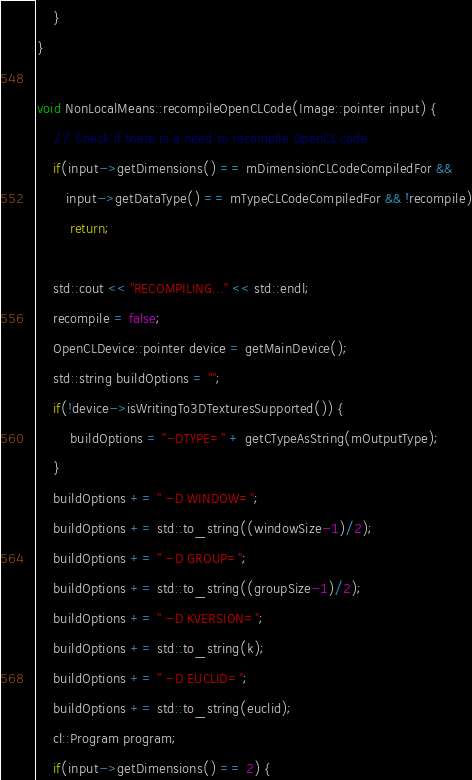Convert code to text. <code><loc_0><loc_0><loc_500><loc_500><_C++_>    }
}

void NonLocalMeans::recompileOpenCLCode(Image::pointer input) {
    // Check if there is a need to recompile OpenCL code
    if(input->getDimensions() == mDimensionCLCodeCompiledFor &&
       input->getDataType() == mTypeCLCodeCompiledFor && !recompile)
        return;

    std::cout << "RECOMPILING..." << std::endl;
    recompile = false;
    OpenCLDevice::pointer device = getMainDevice();
    std::string buildOptions = "";
    if(!device->isWritingTo3DTexturesSupported()) {
        buildOptions = "-DTYPE=" + getCTypeAsString(mOutputType);
    }
    buildOptions += " -D WINDOW=";
    buildOptions += std::to_string((windowSize-1)/2);
    buildOptions += " -D GROUP=";
    buildOptions += std::to_string((groupSize-1)/2);
    buildOptions += " -D KVERSION=";
    buildOptions += std::to_string(k);
    buildOptions += " -D EUCLID=";
    buildOptions += std::to_string(euclid);
    cl::Program program;
    if(input->getDimensions() == 2) {</code> 